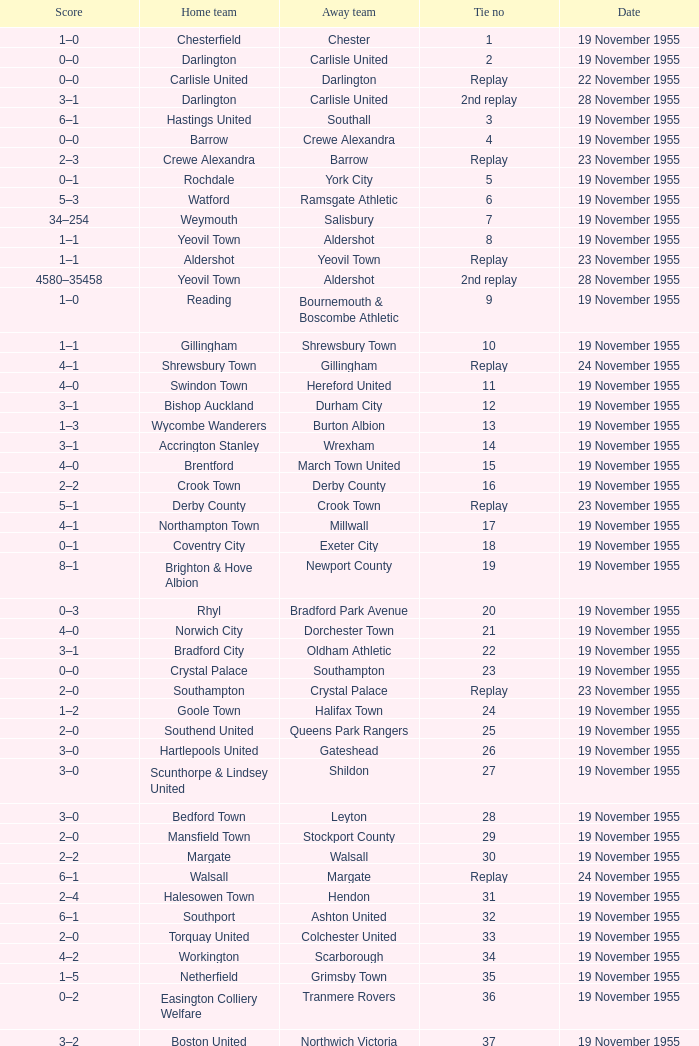What is the home team with scarborough as the away team? Workington. 